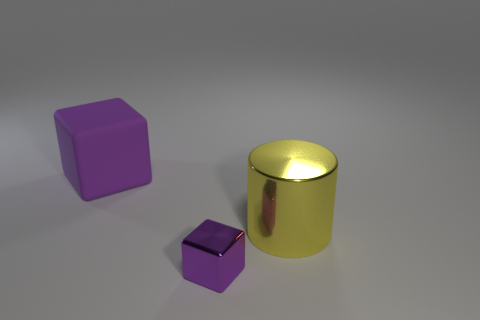What material appears to be the one used for the cylindrical object? The cylindrical object's shiny and reflective surface suggests that it's made of a metallic material, likely intended to resemble gold or a gold-plated metal. 